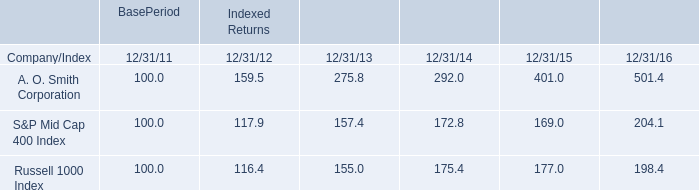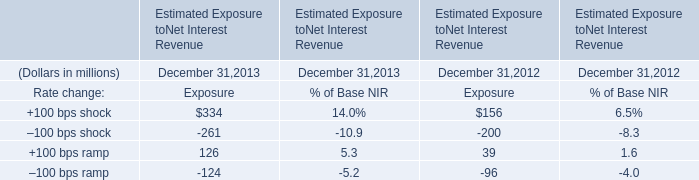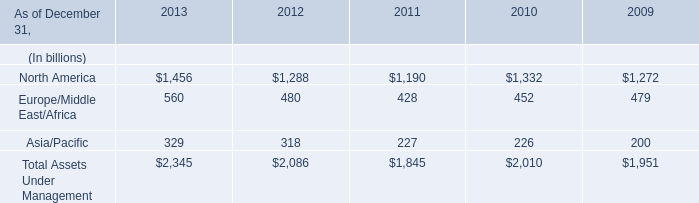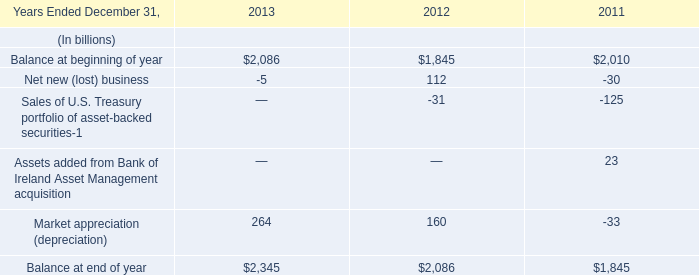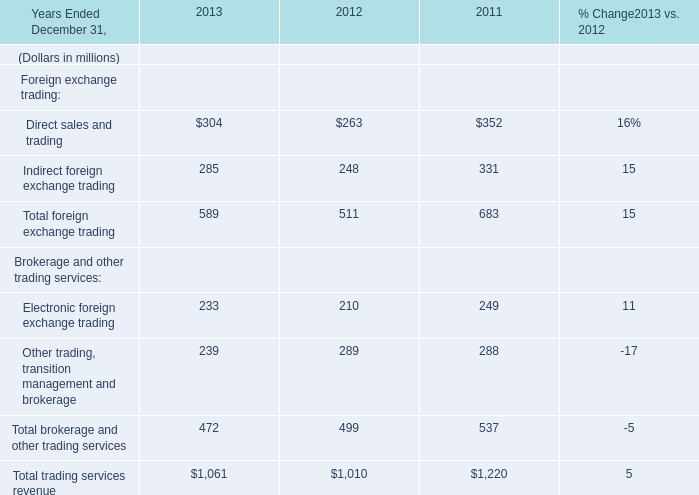What was the total amount of Foreign exchange trading in 2013? (in million) 
Computations: (304 + 285)
Answer: 589.0. 